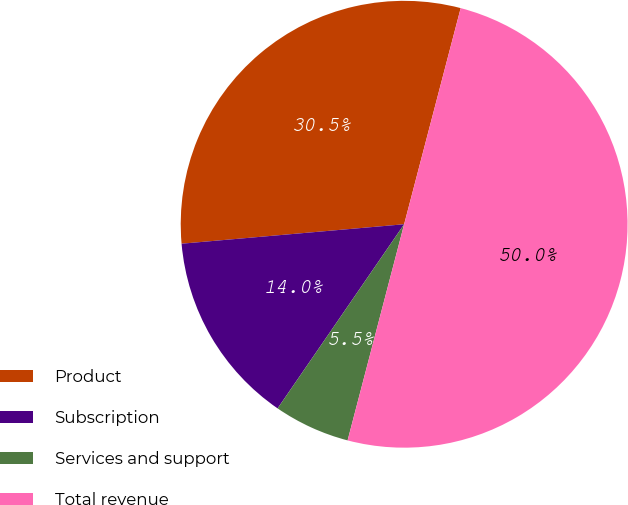Convert chart to OTSL. <chart><loc_0><loc_0><loc_500><loc_500><pie_chart><fcel>Product<fcel>Subscription<fcel>Services and support<fcel>Total revenue<nl><fcel>30.46%<fcel>14.03%<fcel>5.51%<fcel>50.0%<nl></chart> 